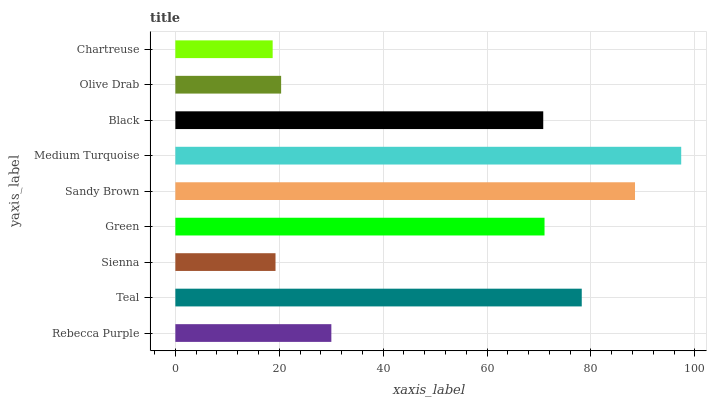Is Chartreuse the minimum?
Answer yes or no. Yes. Is Medium Turquoise the maximum?
Answer yes or no. Yes. Is Teal the minimum?
Answer yes or no. No. Is Teal the maximum?
Answer yes or no. No. Is Teal greater than Rebecca Purple?
Answer yes or no. Yes. Is Rebecca Purple less than Teal?
Answer yes or no. Yes. Is Rebecca Purple greater than Teal?
Answer yes or no. No. Is Teal less than Rebecca Purple?
Answer yes or no. No. Is Black the high median?
Answer yes or no. Yes. Is Black the low median?
Answer yes or no. Yes. Is Teal the high median?
Answer yes or no. No. Is Medium Turquoise the low median?
Answer yes or no. No. 